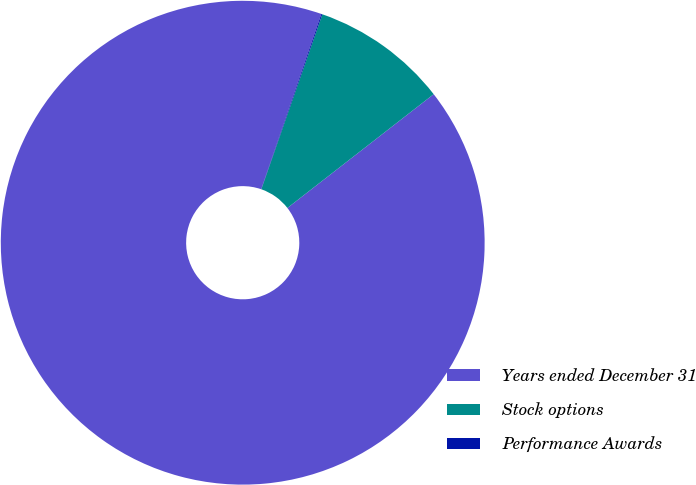Convert chart. <chart><loc_0><loc_0><loc_500><loc_500><pie_chart><fcel>Years ended December 31<fcel>Stock options<fcel>Performance Awards<nl><fcel>90.79%<fcel>9.14%<fcel>0.07%<nl></chart> 